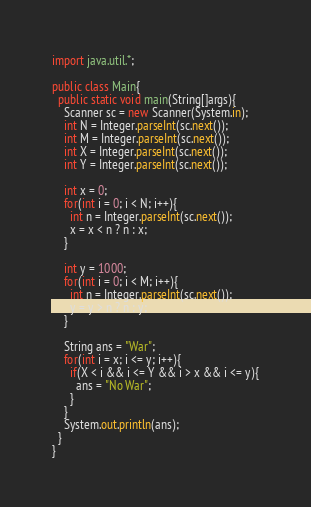Convert code to text. <code><loc_0><loc_0><loc_500><loc_500><_Java_>import java.util.*;

public class Main{
  public static void main(String[]args){
    Scanner sc = new Scanner(System.in);
    int N = Integer.parseInt(sc.next());
    int M = Integer.parseInt(sc.next());
    int X = Integer.parseInt(sc.next());
    int Y = Integer.parseInt(sc.next());
    
    int x = 0;
    for(int i = 0; i < N; i++){
      int n = Integer.parseInt(sc.next());
      x = x < n ? n : x;
    }
    
    int y = 1000;
    for(int i = 0; i < M; i++){
      int n = Integer.parseInt(sc.next());
      y = y > n ? n : y;
    }
    
    String ans = "War";
    for(int i = x; i <= y; i++){
      if(X < i && i <= Y && i > x && i <= y){
        ans = "No War";
      }
    }
    System.out.println(ans);
  }
}</code> 